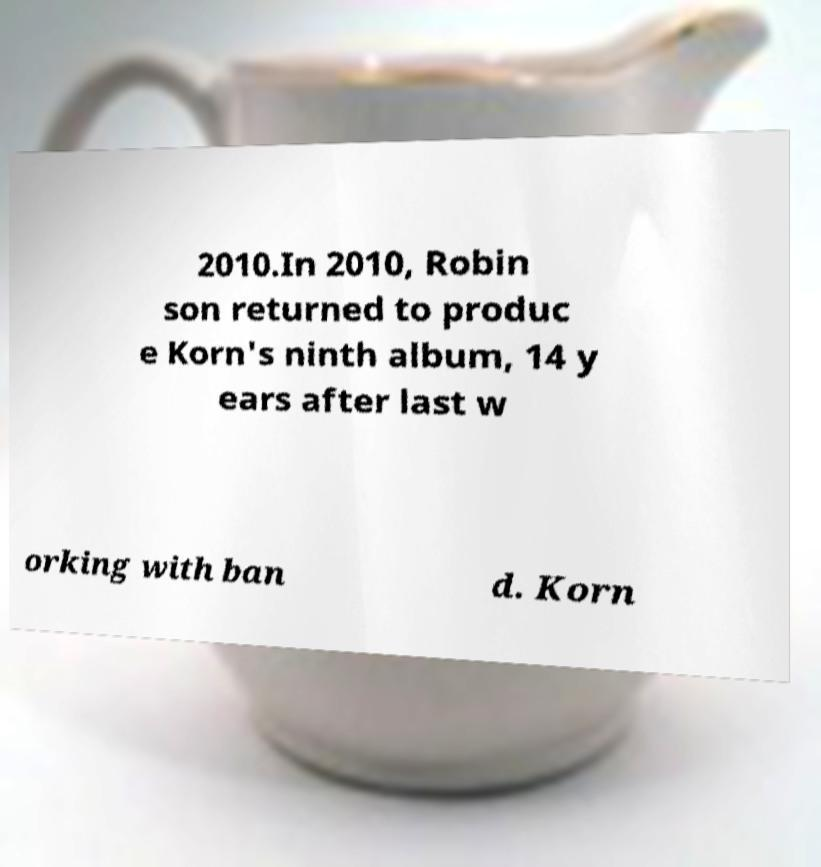There's text embedded in this image that I need extracted. Can you transcribe it verbatim? 2010.In 2010, Robin son returned to produc e Korn's ninth album, 14 y ears after last w orking with ban d. Korn 